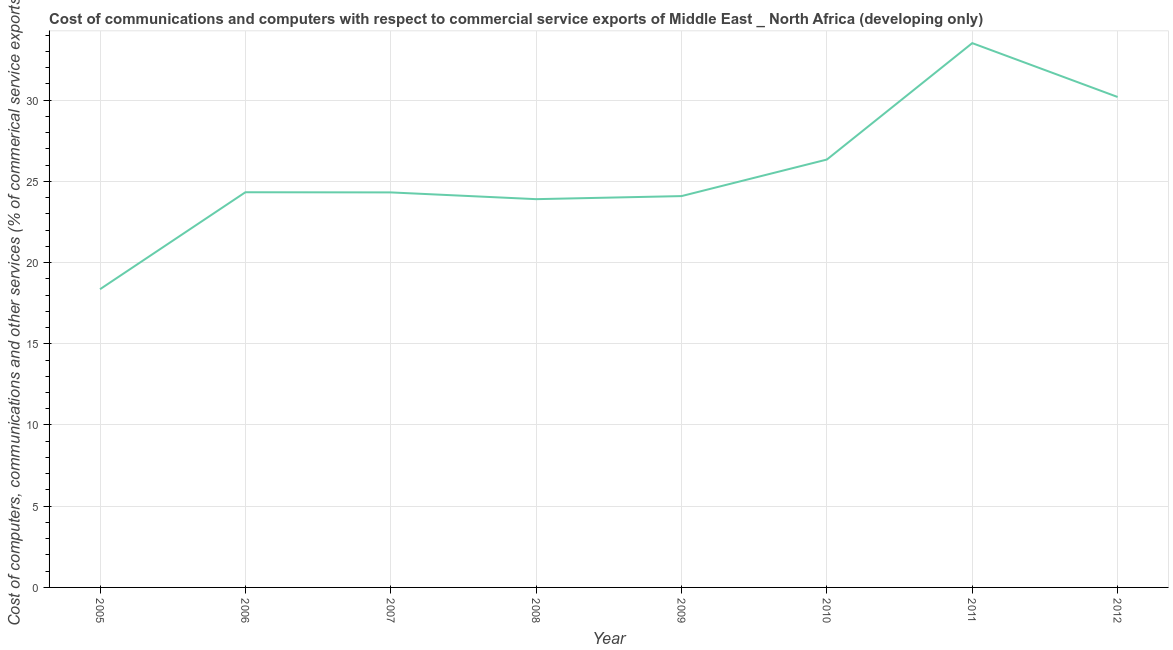What is the  computer and other services in 2010?
Provide a succinct answer. 26.34. Across all years, what is the maximum cost of communications?
Your answer should be very brief. 33.51. Across all years, what is the minimum cost of communications?
Provide a short and direct response. 18.36. In which year was the cost of communications maximum?
Offer a very short reply. 2011. What is the sum of the cost of communications?
Your response must be concise. 205.05. What is the difference between the  computer and other services in 2006 and 2011?
Ensure brevity in your answer.  -9.18. What is the average  computer and other services per year?
Give a very brief answer. 25.63. What is the median  computer and other services?
Your response must be concise. 24.32. In how many years, is the  computer and other services greater than 24 %?
Give a very brief answer. 6. Do a majority of the years between 2011 and 2012 (inclusive) have  computer and other services greater than 2 %?
Offer a terse response. Yes. What is the ratio of the  computer and other services in 2009 to that in 2010?
Your answer should be compact. 0.91. What is the difference between the highest and the second highest  computer and other services?
Make the answer very short. 3.32. Is the sum of the cost of communications in 2008 and 2010 greater than the maximum cost of communications across all years?
Give a very brief answer. Yes. What is the difference between the highest and the lowest  computer and other services?
Ensure brevity in your answer.  15.15. In how many years, is the cost of communications greater than the average cost of communications taken over all years?
Offer a very short reply. 3. Does the cost of communications monotonically increase over the years?
Your response must be concise. No. How many lines are there?
Give a very brief answer. 1. Are the values on the major ticks of Y-axis written in scientific E-notation?
Give a very brief answer. No. Does the graph contain any zero values?
Provide a short and direct response. No. Does the graph contain grids?
Your response must be concise. Yes. What is the title of the graph?
Your response must be concise. Cost of communications and computers with respect to commercial service exports of Middle East _ North Africa (developing only). What is the label or title of the X-axis?
Ensure brevity in your answer.  Year. What is the label or title of the Y-axis?
Provide a short and direct response. Cost of computers, communications and other services (% of commerical service exports). What is the Cost of computers, communications and other services (% of commerical service exports) in 2005?
Give a very brief answer. 18.36. What is the Cost of computers, communications and other services (% of commerical service exports) of 2006?
Ensure brevity in your answer.  24.33. What is the Cost of computers, communications and other services (% of commerical service exports) in 2007?
Your answer should be compact. 24.32. What is the Cost of computers, communications and other services (% of commerical service exports) in 2008?
Give a very brief answer. 23.9. What is the Cost of computers, communications and other services (% of commerical service exports) in 2009?
Your answer should be very brief. 24.09. What is the Cost of computers, communications and other services (% of commerical service exports) in 2010?
Give a very brief answer. 26.34. What is the Cost of computers, communications and other services (% of commerical service exports) in 2011?
Your response must be concise. 33.51. What is the Cost of computers, communications and other services (% of commerical service exports) of 2012?
Your answer should be compact. 30.19. What is the difference between the Cost of computers, communications and other services (% of commerical service exports) in 2005 and 2006?
Your response must be concise. -5.97. What is the difference between the Cost of computers, communications and other services (% of commerical service exports) in 2005 and 2007?
Provide a short and direct response. -5.96. What is the difference between the Cost of computers, communications and other services (% of commerical service exports) in 2005 and 2008?
Give a very brief answer. -5.55. What is the difference between the Cost of computers, communications and other services (% of commerical service exports) in 2005 and 2009?
Give a very brief answer. -5.73. What is the difference between the Cost of computers, communications and other services (% of commerical service exports) in 2005 and 2010?
Keep it short and to the point. -7.98. What is the difference between the Cost of computers, communications and other services (% of commerical service exports) in 2005 and 2011?
Offer a terse response. -15.15. What is the difference between the Cost of computers, communications and other services (% of commerical service exports) in 2005 and 2012?
Provide a succinct answer. -11.84. What is the difference between the Cost of computers, communications and other services (% of commerical service exports) in 2006 and 2007?
Give a very brief answer. 0.01. What is the difference between the Cost of computers, communications and other services (% of commerical service exports) in 2006 and 2008?
Make the answer very short. 0.43. What is the difference between the Cost of computers, communications and other services (% of commerical service exports) in 2006 and 2009?
Your answer should be compact. 0.24. What is the difference between the Cost of computers, communications and other services (% of commerical service exports) in 2006 and 2010?
Make the answer very short. -2.01. What is the difference between the Cost of computers, communications and other services (% of commerical service exports) in 2006 and 2011?
Offer a very short reply. -9.18. What is the difference between the Cost of computers, communications and other services (% of commerical service exports) in 2006 and 2012?
Your answer should be very brief. -5.87. What is the difference between the Cost of computers, communications and other services (% of commerical service exports) in 2007 and 2008?
Provide a succinct answer. 0.42. What is the difference between the Cost of computers, communications and other services (% of commerical service exports) in 2007 and 2009?
Provide a succinct answer. 0.23. What is the difference between the Cost of computers, communications and other services (% of commerical service exports) in 2007 and 2010?
Provide a succinct answer. -2.02. What is the difference between the Cost of computers, communications and other services (% of commerical service exports) in 2007 and 2011?
Make the answer very short. -9.19. What is the difference between the Cost of computers, communications and other services (% of commerical service exports) in 2007 and 2012?
Your response must be concise. -5.88. What is the difference between the Cost of computers, communications and other services (% of commerical service exports) in 2008 and 2009?
Provide a short and direct response. -0.19. What is the difference between the Cost of computers, communications and other services (% of commerical service exports) in 2008 and 2010?
Provide a succinct answer. -2.44. What is the difference between the Cost of computers, communications and other services (% of commerical service exports) in 2008 and 2011?
Give a very brief answer. -9.61. What is the difference between the Cost of computers, communications and other services (% of commerical service exports) in 2008 and 2012?
Make the answer very short. -6.29. What is the difference between the Cost of computers, communications and other services (% of commerical service exports) in 2009 and 2010?
Your response must be concise. -2.25. What is the difference between the Cost of computers, communications and other services (% of commerical service exports) in 2009 and 2011?
Ensure brevity in your answer.  -9.42. What is the difference between the Cost of computers, communications and other services (% of commerical service exports) in 2009 and 2012?
Offer a very short reply. -6.1. What is the difference between the Cost of computers, communications and other services (% of commerical service exports) in 2010 and 2011?
Make the answer very short. -7.17. What is the difference between the Cost of computers, communications and other services (% of commerical service exports) in 2010 and 2012?
Give a very brief answer. -3.85. What is the difference between the Cost of computers, communications and other services (% of commerical service exports) in 2011 and 2012?
Provide a succinct answer. 3.32. What is the ratio of the Cost of computers, communications and other services (% of commerical service exports) in 2005 to that in 2006?
Give a very brief answer. 0.76. What is the ratio of the Cost of computers, communications and other services (% of commerical service exports) in 2005 to that in 2007?
Provide a short and direct response. 0.76. What is the ratio of the Cost of computers, communications and other services (% of commerical service exports) in 2005 to that in 2008?
Keep it short and to the point. 0.77. What is the ratio of the Cost of computers, communications and other services (% of commerical service exports) in 2005 to that in 2009?
Provide a succinct answer. 0.76. What is the ratio of the Cost of computers, communications and other services (% of commerical service exports) in 2005 to that in 2010?
Give a very brief answer. 0.7. What is the ratio of the Cost of computers, communications and other services (% of commerical service exports) in 2005 to that in 2011?
Give a very brief answer. 0.55. What is the ratio of the Cost of computers, communications and other services (% of commerical service exports) in 2005 to that in 2012?
Your response must be concise. 0.61. What is the ratio of the Cost of computers, communications and other services (% of commerical service exports) in 2006 to that in 2007?
Offer a very short reply. 1. What is the ratio of the Cost of computers, communications and other services (% of commerical service exports) in 2006 to that in 2009?
Your answer should be compact. 1.01. What is the ratio of the Cost of computers, communications and other services (% of commerical service exports) in 2006 to that in 2010?
Offer a terse response. 0.92. What is the ratio of the Cost of computers, communications and other services (% of commerical service exports) in 2006 to that in 2011?
Give a very brief answer. 0.73. What is the ratio of the Cost of computers, communications and other services (% of commerical service exports) in 2006 to that in 2012?
Offer a very short reply. 0.81. What is the ratio of the Cost of computers, communications and other services (% of commerical service exports) in 2007 to that in 2009?
Give a very brief answer. 1.01. What is the ratio of the Cost of computers, communications and other services (% of commerical service exports) in 2007 to that in 2010?
Provide a succinct answer. 0.92. What is the ratio of the Cost of computers, communications and other services (% of commerical service exports) in 2007 to that in 2011?
Ensure brevity in your answer.  0.73. What is the ratio of the Cost of computers, communications and other services (% of commerical service exports) in 2007 to that in 2012?
Offer a terse response. 0.81. What is the ratio of the Cost of computers, communications and other services (% of commerical service exports) in 2008 to that in 2009?
Keep it short and to the point. 0.99. What is the ratio of the Cost of computers, communications and other services (% of commerical service exports) in 2008 to that in 2010?
Make the answer very short. 0.91. What is the ratio of the Cost of computers, communications and other services (% of commerical service exports) in 2008 to that in 2011?
Make the answer very short. 0.71. What is the ratio of the Cost of computers, communications and other services (% of commerical service exports) in 2008 to that in 2012?
Your answer should be compact. 0.79. What is the ratio of the Cost of computers, communications and other services (% of commerical service exports) in 2009 to that in 2010?
Provide a short and direct response. 0.92. What is the ratio of the Cost of computers, communications and other services (% of commerical service exports) in 2009 to that in 2011?
Ensure brevity in your answer.  0.72. What is the ratio of the Cost of computers, communications and other services (% of commerical service exports) in 2009 to that in 2012?
Keep it short and to the point. 0.8. What is the ratio of the Cost of computers, communications and other services (% of commerical service exports) in 2010 to that in 2011?
Provide a succinct answer. 0.79. What is the ratio of the Cost of computers, communications and other services (% of commerical service exports) in 2010 to that in 2012?
Provide a short and direct response. 0.87. What is the ratio of the Cost of computers, communications and other services (% of commerical service exports) in 2011 to that in 2012?
Offer a terse response. 1.11. 